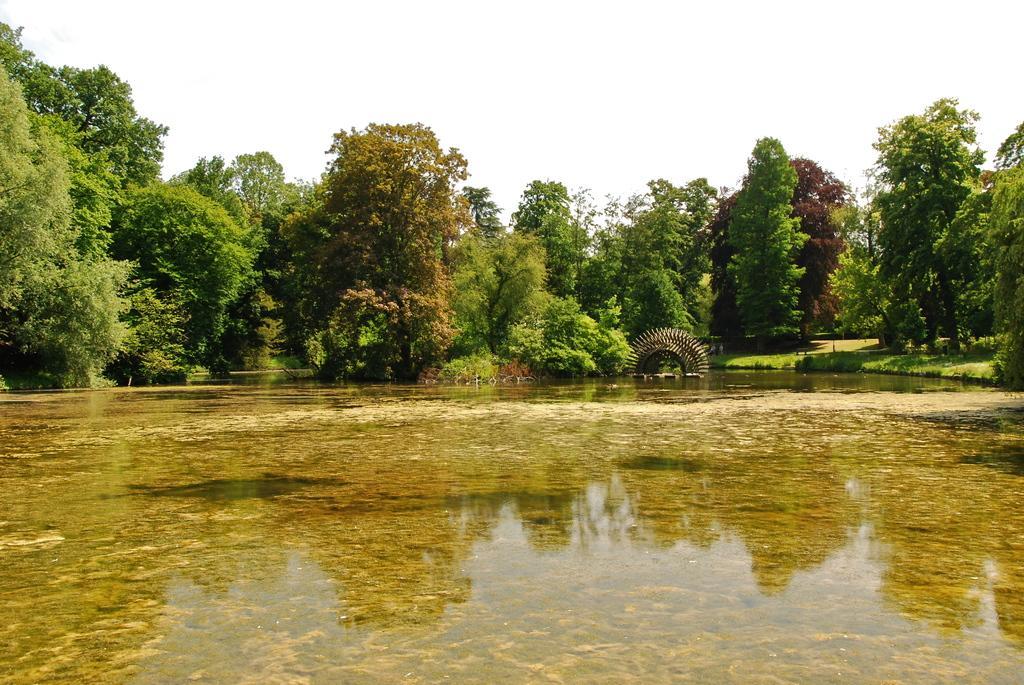Could you give a brief overview of what you see in this image? Front we can see water. Background there are trees. 